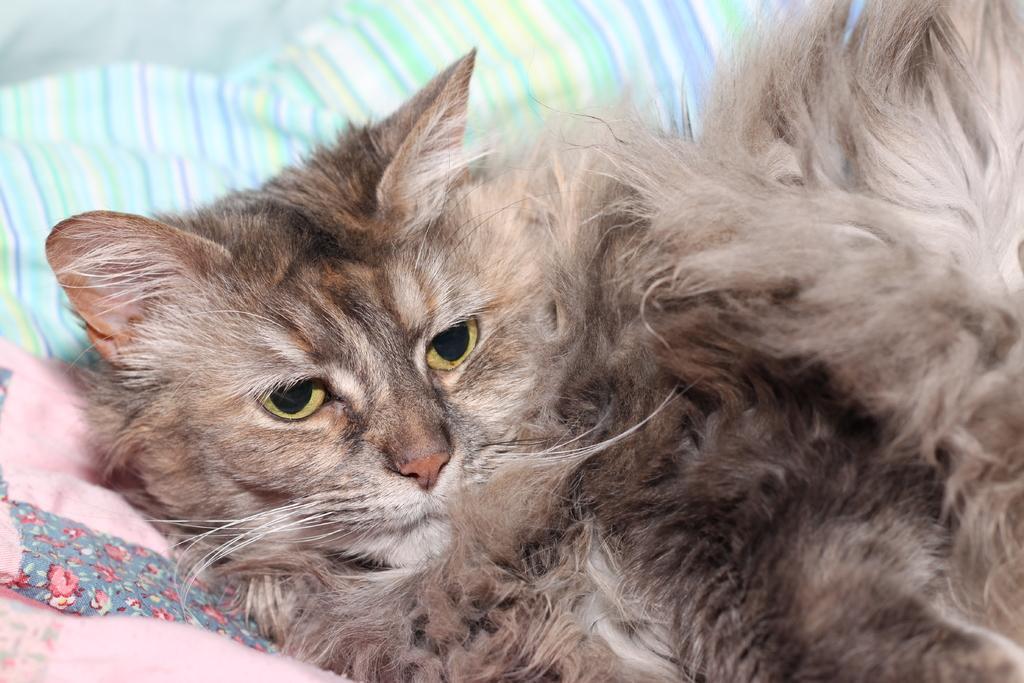How would you summarize this image in a sentence or two? In the image there is a cat laying on pillows. 